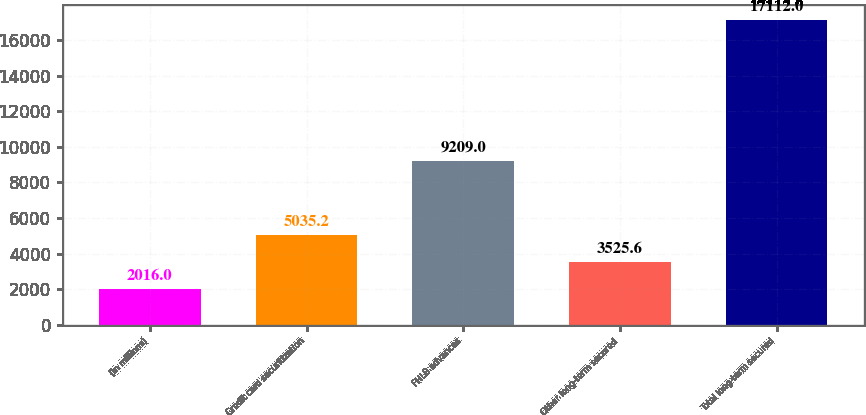<chart> <loc_0><loc_0><loc_500><loc_500><bar_chart><fcel>(in millions)<fcel>Credit card securitization<fcel>FHLB advances<fcel>Other long-term secured<fcel>Total long-term secured<nl><fcel>2016<fcel>5035.2<fcel>9209<fcel>3525.6<fcel>17112<nl></chart> 